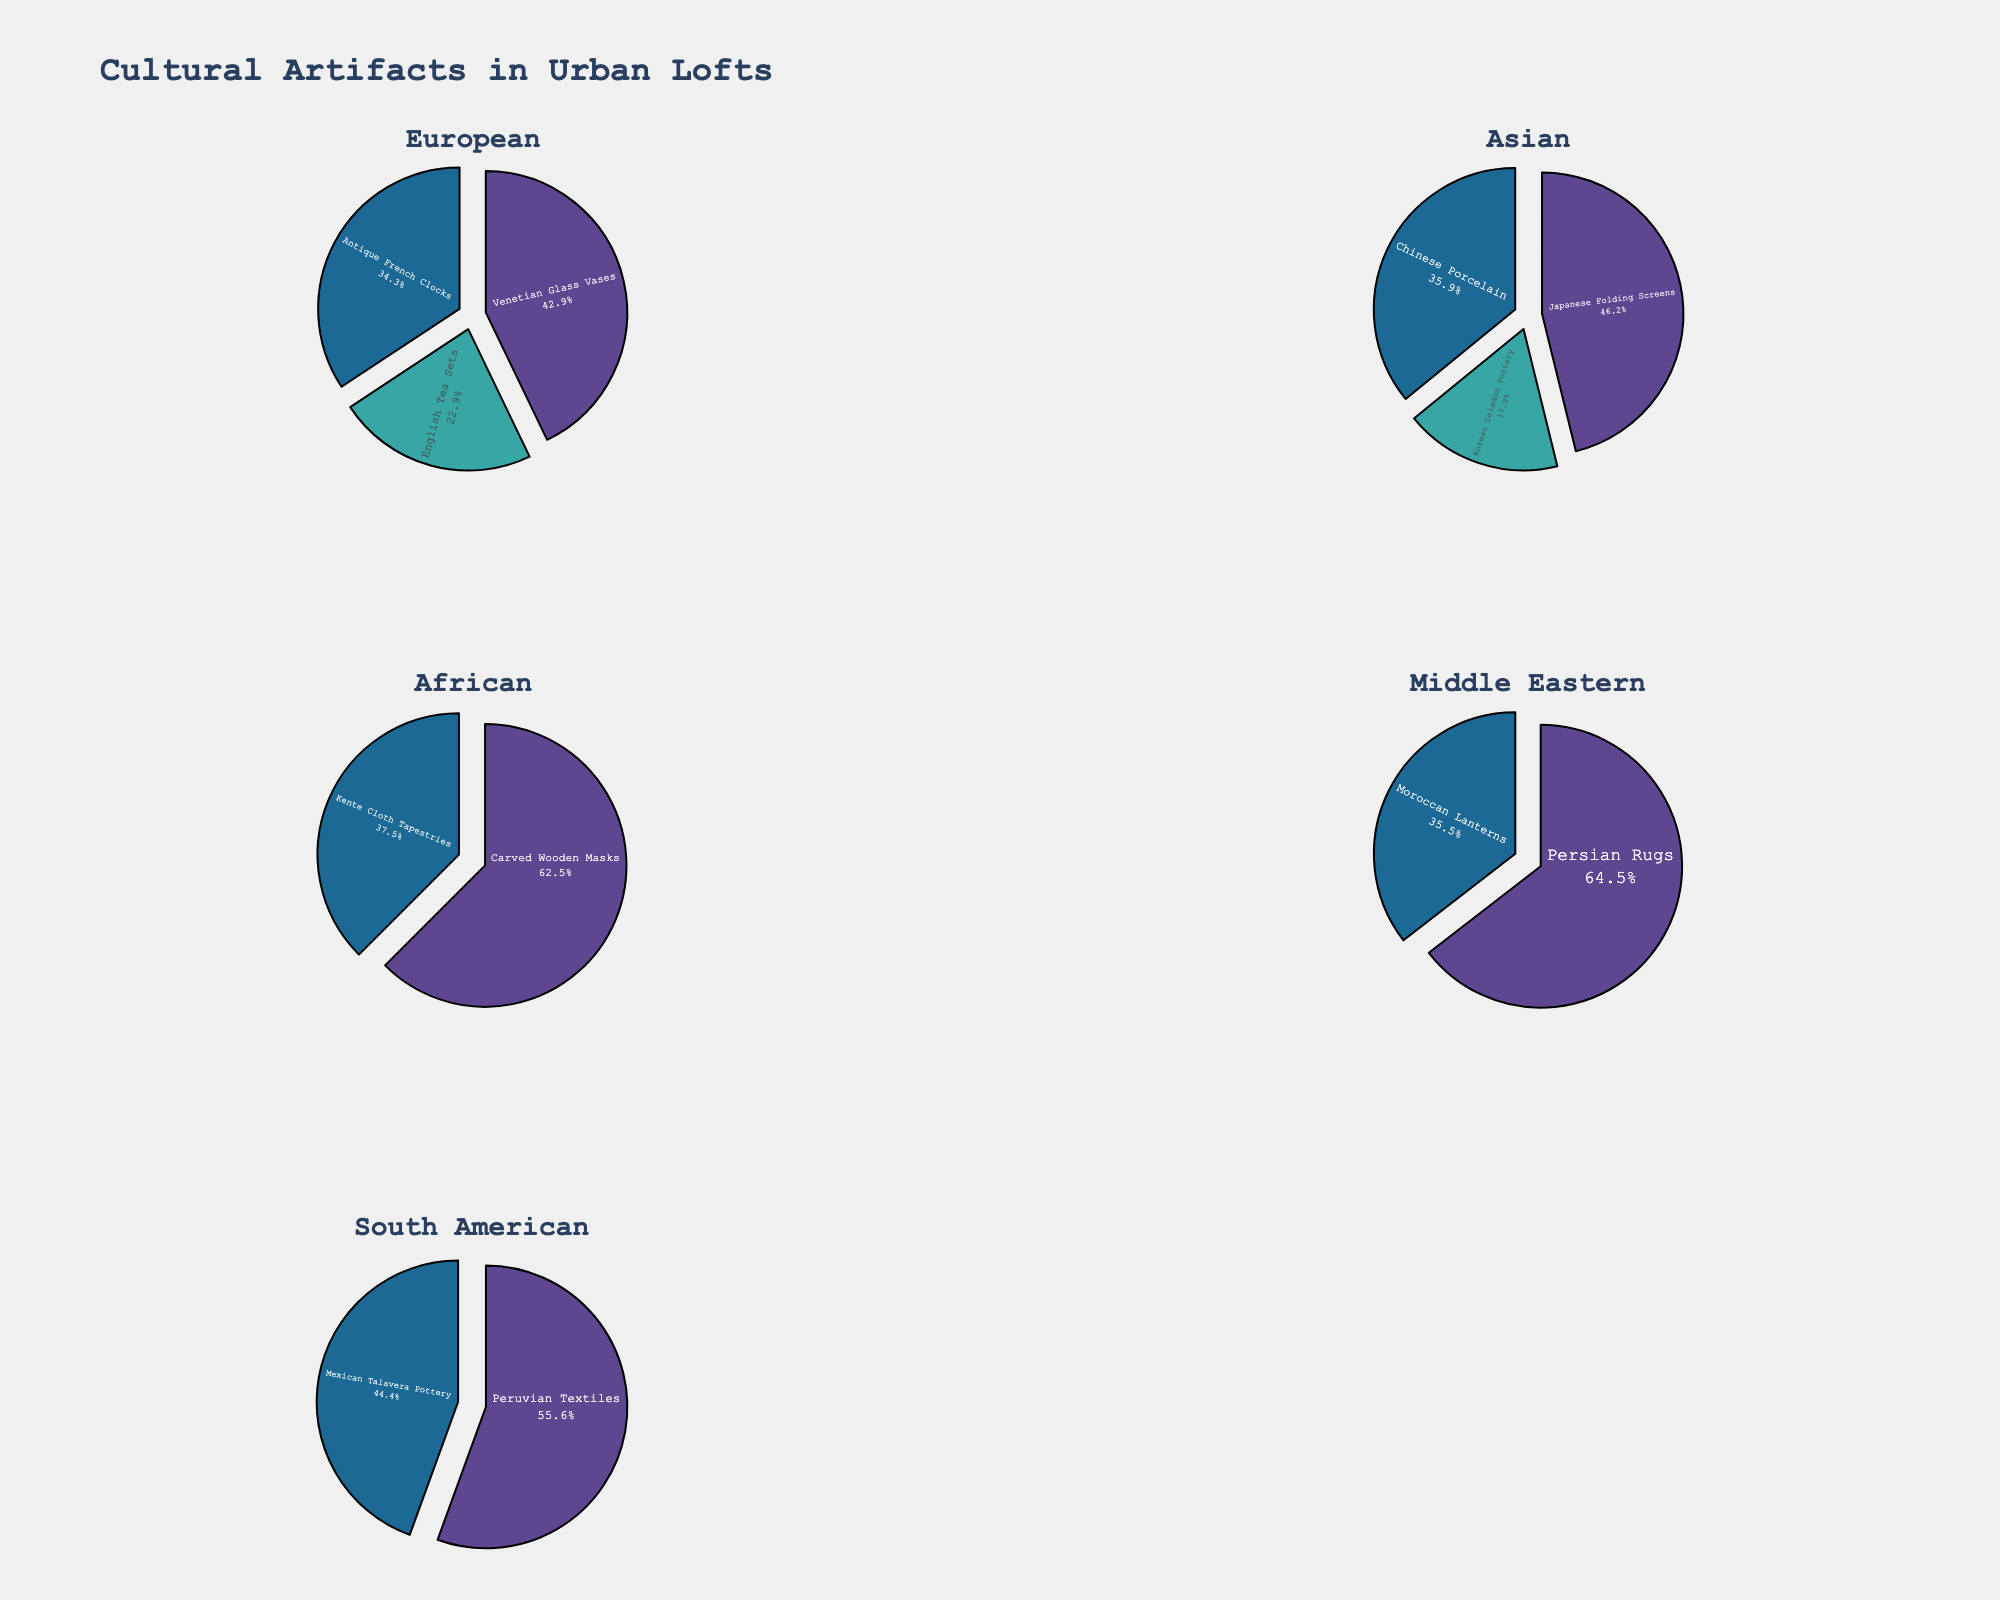What's the title of the figure? The title of the figure is displayed at the top and is centered within the figure layout.
Answer: Personality Traits in White-Collar Criminals Across Industries Which industry has the highest prevalence of Narcissism? Looking at the bar representing Narcissism in each subplot, the bar for the Finance industry reaches the highest value.
Answer: Finance What is the average Machiavellianism score across all industries? Sum all Machiavellianism scores (82 + 70 + 76 + 79 + 74 + 72 + 73 + 75 + 78 + 71) which equals 750, then divide by the number of industries, 10.
Answer: 75 How does the prevalence of Risk-taking in Finance compare to that in Technology? Locate the Risk-taking bar for the Finance and Technology industries and compare their heights; the values are 72 (Finance) and 75 (Technology) respectively, with Technology being higher.
Answer: Technology > Finance Which industry has the lowest value in the Psychopathy trait? By identifying the lowest bar in the Psychopathy subplot, Healthcare has the lowest value, represented by a value of 53.
Answer: Healthcare Which trait has the highest value for the Real Estate industry? Each subplot corresponds to one personality trait. Identifying the highest bar among the Real Estate industry bars, Machiavellianism has the highest value at 79.
Answer: Machiavellianism What is the difference between the highest and lowest Impulsivity scores across industries? The highest Impulsivity score is 67 (Technology), and the lowest is 58 (Finance); the difference is 67 - 58.
Answer: 9 For the Pharmaceuticals industry, which two traits have the smallest difference in prevalence? By comparing the values of each trait within the Pharmaceuticals industry, the closest values are Impulsivity (65) and Risk-taking (67), which differ by 2.
Answer: Impulsivity and Risk-taking What is the general trend in Psychopathy scores across industries? Psychopathy scores vary but generally fall between 53 and 65 across different industries, indicating a relatively lower and more consistent prevalence compared to other traits.
Answer: Generally low and consistent 